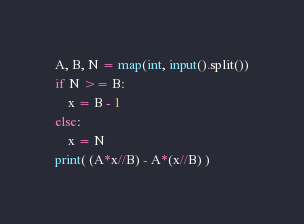Convert code to text. <code><loc_0><loc_0><loc_500><loc_500><_Python_>A, B, N = map(int, input().split())
if N >= B:
    x = B - 1
else:
    x = N
print( (A*x//B) - A*(x//B) )</code> 